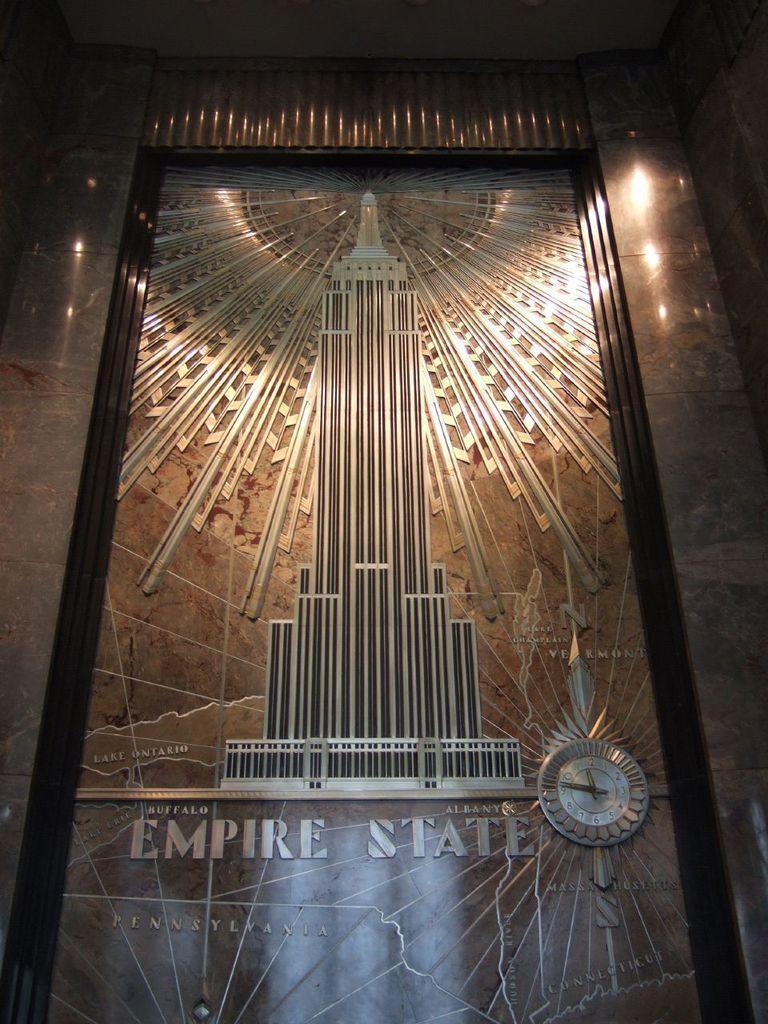How would you summarize this image in a sentence or two? In this image, we can see there is a frame. In this frame, there is a clock, there are texts, a design of a building and other designs. This frame is attached to the wall, on which there are lights. 